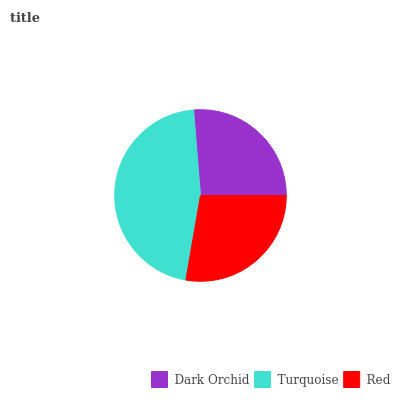Is Dark Orchid the minimum?
Answer yes or no. Yes. Is Turquoise the maximum?
Answer yes or no. Yes. Is Red the minimum?
Answer yes or no. No. Is Red the maximum?
Answer yes or no. No. Is Turquoise greater than Red?
Answer yes or no. Yes. Is Red less than Turquoise?
Answer yes or no. Yes. Is Red greater than Turquoise?
Answer yes or no. No. Is Turquoise less than Red?
Answer yes or no. No. Is Red the high median?
Answer yes or no. Yes. Is Red the low median?
Answer yes or no. Yes. Is Turquoise the high median?
Answer yes or no. No. Is Turquoise the low median?
Answer yes or no. No. 